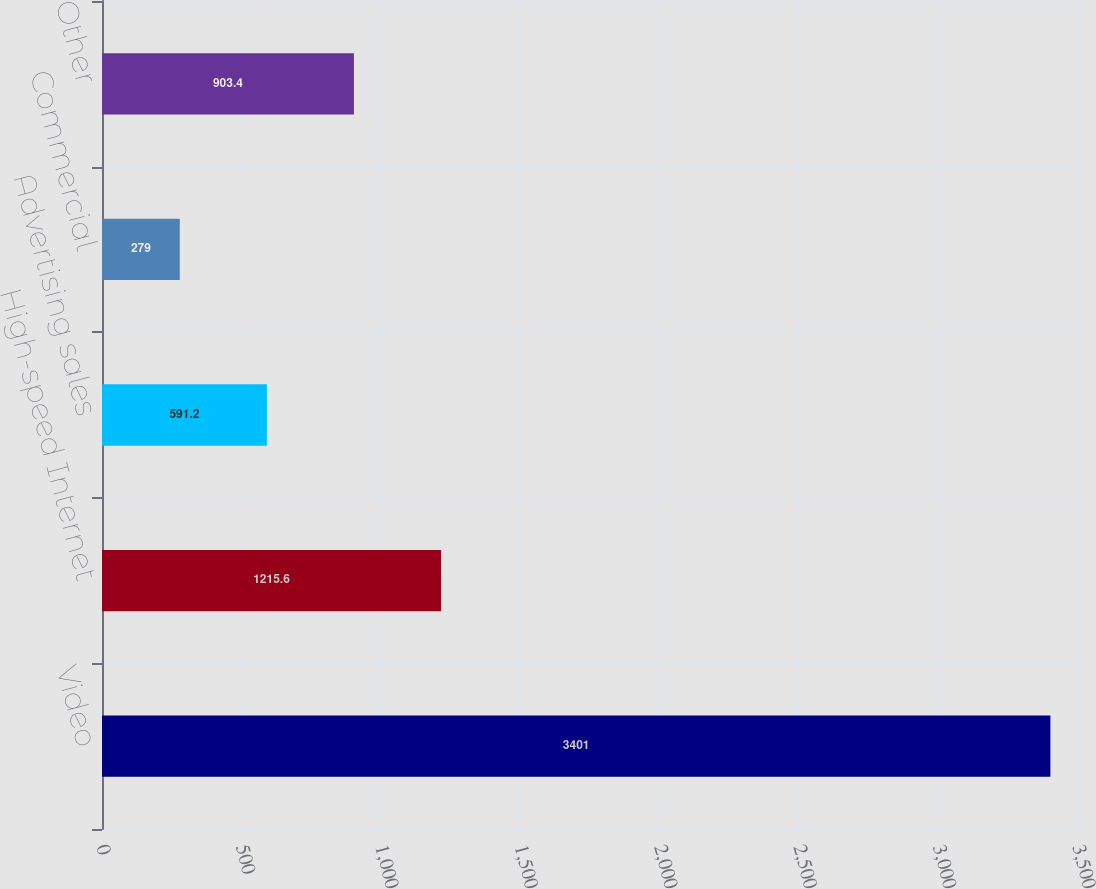<chart> <loc_0><loc_0><loc_500><loc_500><bar_chart><fcel>Video<fcel>High-speed Internet<fcel>Advertising sales<fcel>Commercial<fcel>Other<nl><fcel>3401<fcel>1215.6<fcel>591.2<fcel>279<fcel>903.4<nl></chart> 